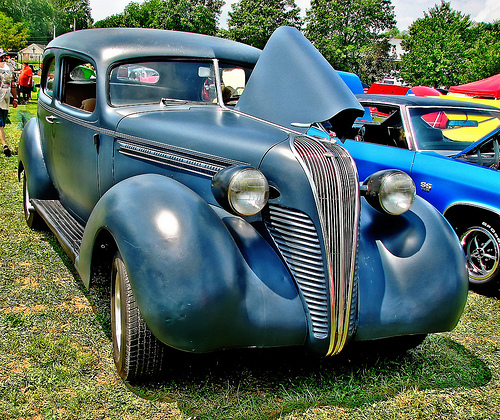<image>
Is the car behind the hood? Yes. From this viewpoint, the car is positioned behind the hood, with the hood partially or fully occluding the car. 